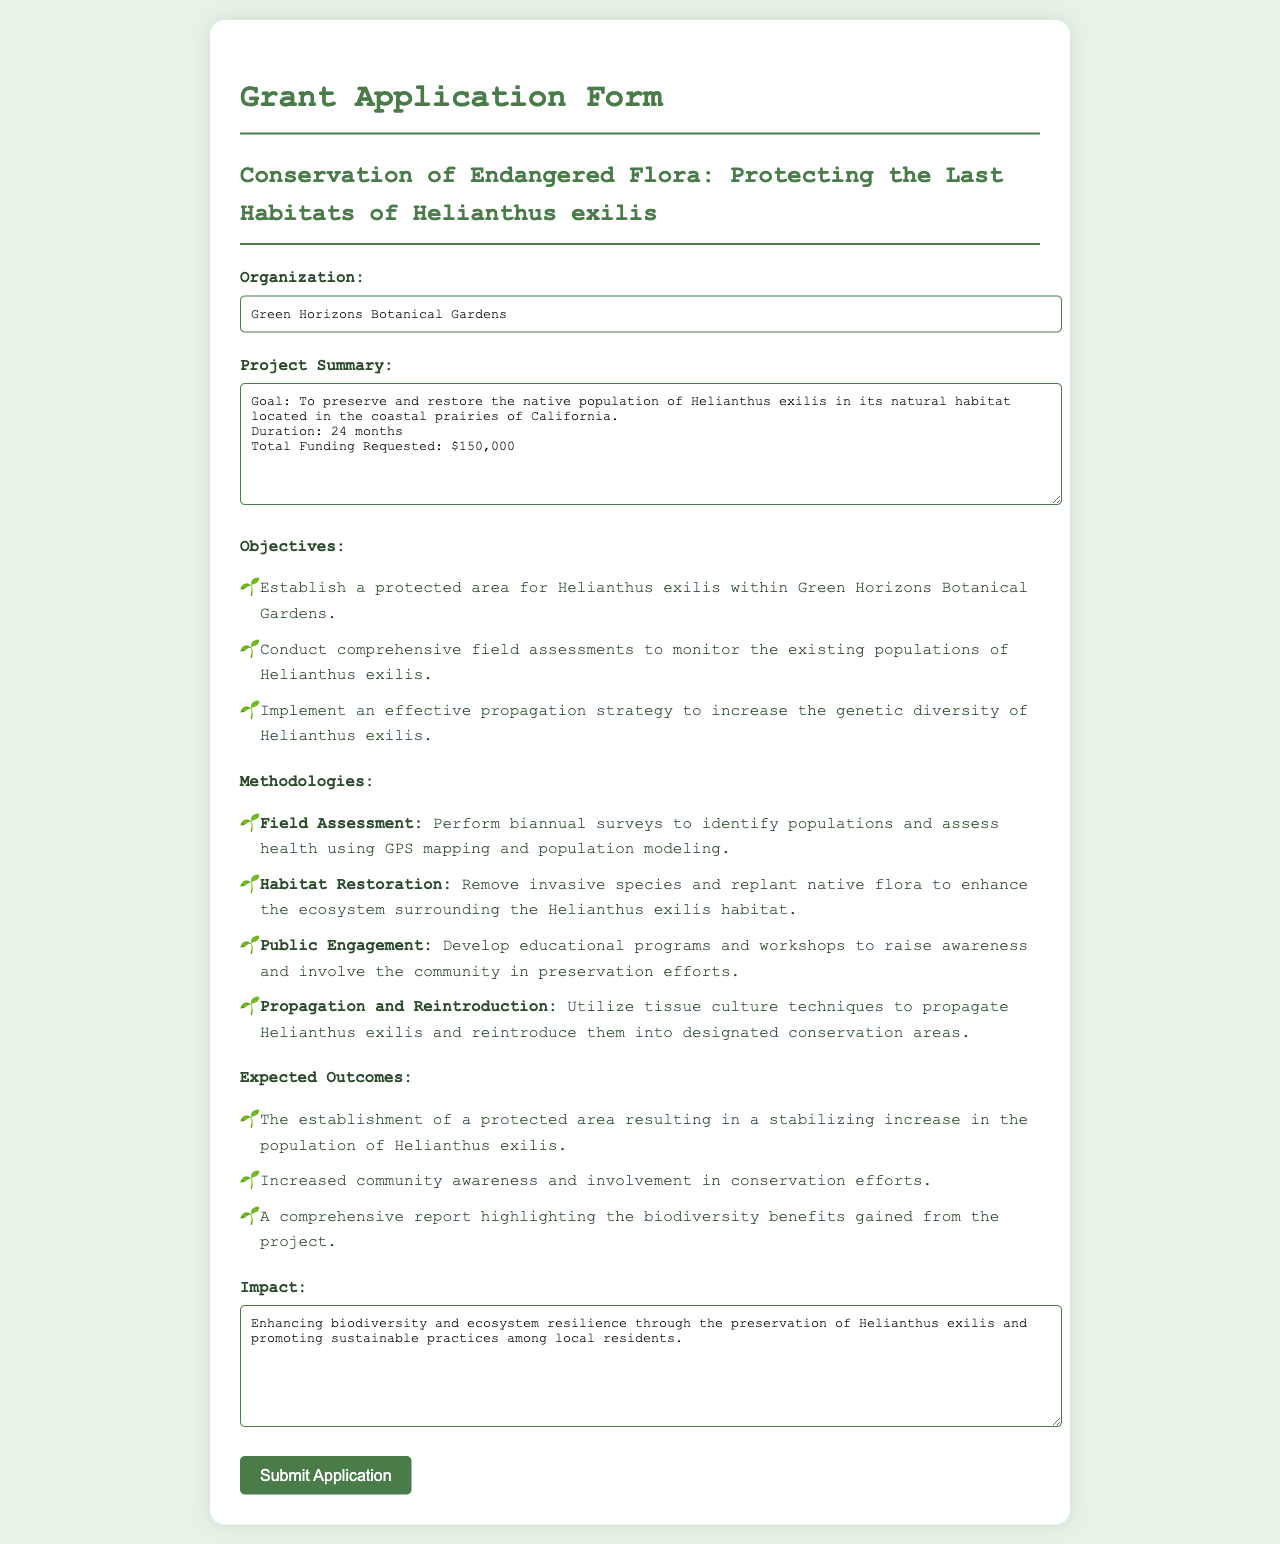what is the organization name? The organization name is stated at the beginning of the document.
Answer: Green Horizons Botanical Gardens what is the total funding requested? The total funding requested is specified in the project summary.
Answer: $150,000 how long is the project duration? The duration of the project is mentioned in the project summary.
Answer: 24 months what is one objective of the project? Objectives are listed in the document, and one can be selected from the provided list.
Answer: Establish a protected area for Helianthus exilis within Green Horizons Botanical Gardens name one methodology used in the project. Methodologies are detailed in the document, providing several options to choose from.
Answer: Field Assessment what is an expected outcome of the project? Expected outcomes are outlined, allowing for specific examples to be provided.
Answer: The establishment of a protected area resulting in a stabilizing increase in the population of Helianthus exilis what is the goal of the project? The goal of the project is summarized in the project summary section.
Answer: To preserve and restore the native population of Helianthus exilis in its natural habitat what is the impact mentioned in the document? The impact is described distinctly towards the end of the document.
Answer: Enhancing biodiversity and ecosystem resilience through the preservation of Helianthus exilis and promoting sustainable practices among local residents 